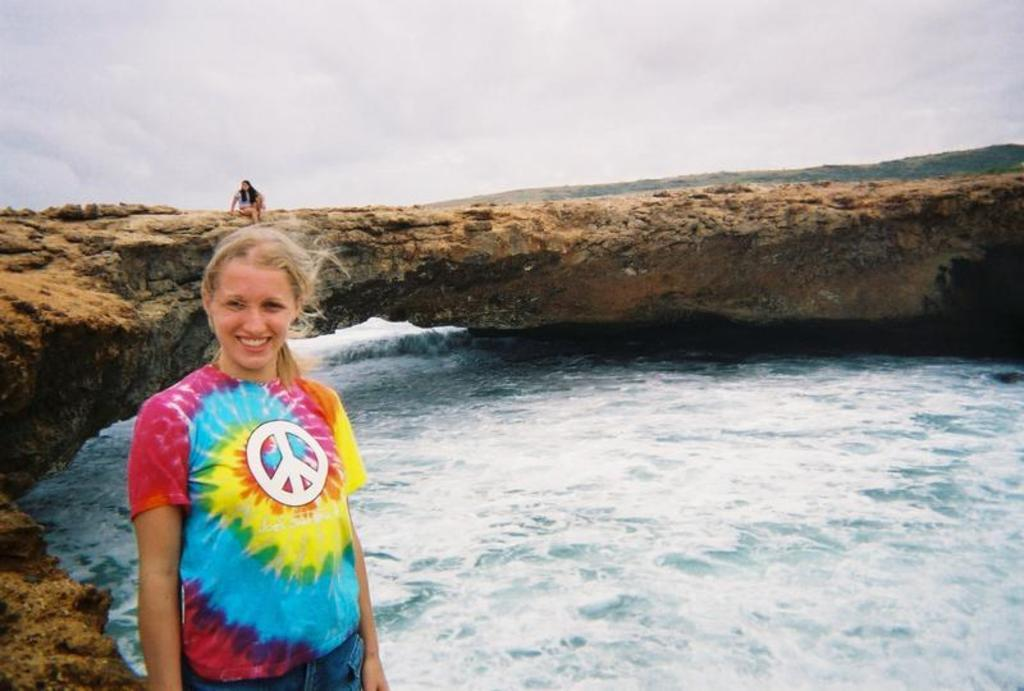What is the woman in the image doing? There is a woman standing in the image. What is near the standing woman? There is water beside the standing woman. Can you describe the position of the other woman in the image? There is another woman sitting on a rock in the image. Where is the rock located in relation to the standing woman? The rock is behind the standing woman. How would you describe the weather in the image? The sky is cloudy in the image. What type of debt is the woman standing in the image trying to pay off? There is no mention of debt in the image, and therefore it cannot be determined if the woman is trying to pay off any debt. Can you describe the iron content of the water near the standing woman? There is no information about the iron content of the water in the image, so it cannot be determined. 